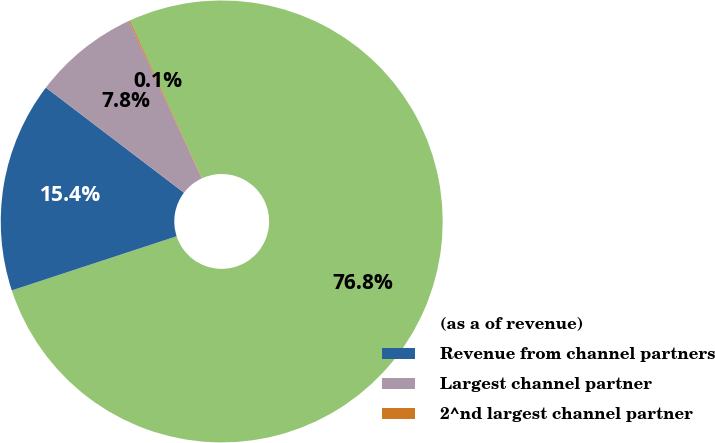Convert chart. <chart><loc_0><loc_0><loc_500><loc_500><pie_chart><fcel>(as a of revenue)<fcel>Revenue from channel partners<fcel>Largest channel partner<fcel>2^nd largest channel partner<nl><fcel>76.76%<fcel>15.41%<fcel>7.75%<fcel>0.08%<nl></chart> 